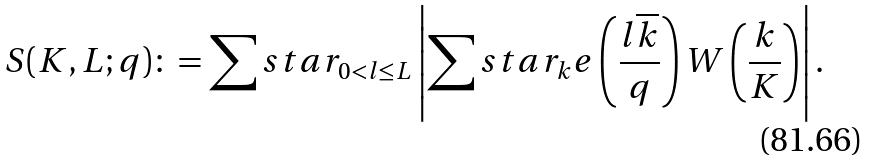Convert formula to latex. <formula><loc_0><loc_0><loc_500><loc_500>S ( K , L ; q ) \colon = \sum s t a r _ { 0 < l \leq L } \left | \sum s t a r _ { k } e \left ( \frac { l \overline { k } } { q } \right ) W \left ( \frac { k } { K } \right ) \right | .</formula> 